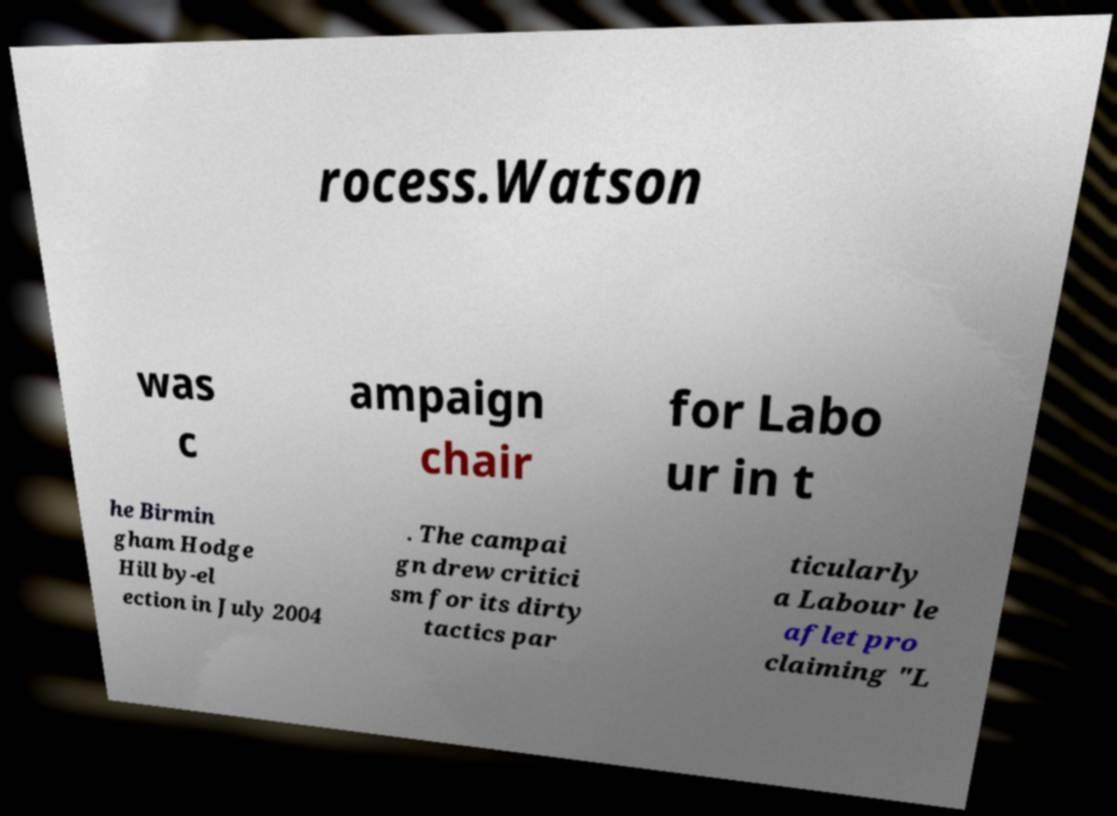There's text embedded in this image that I need extracted. Can you transcribe it verbatim? rocess.Watson was c ampaign chair for Labo ur in t he Birmin gham Hodge Hill by-el ection in July 2004 . The campai gn drew critici sm for its dirty tactics par ticularly a Labour le aflet pro claiming "L 